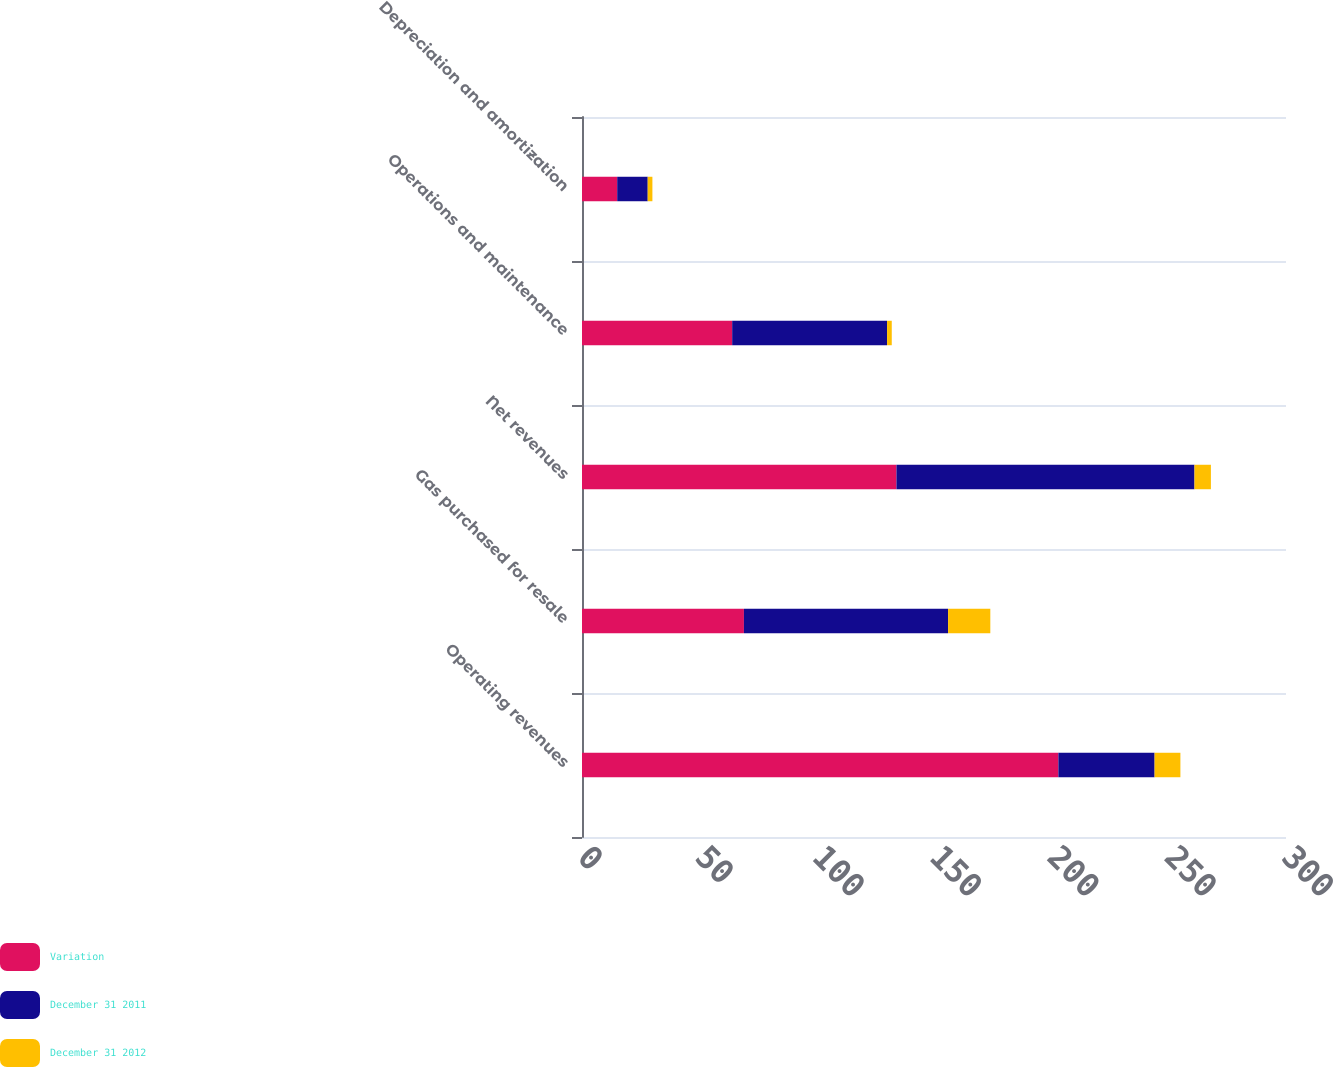<chart> <loc_0><loc_0><loc_500><loc_500><stacked_bar_chart><ecel><fcel>Operating revenues<fcel>Gas purchased for resale<fcel>Net revenues<fcel>Operations and maintenance<fcel>Depreciation and amortization<nl><fcel>Variation<fcel>203<fcel>69<fcel>134<fcel>64<fcel>15<nl><fcel>December 31 2011<fcel>41<fcel>87<fcel>127<fcel>66<fcel>13<nl><fcel>December 31 2012<fcel>11<fcel>18<fcel>7<fcel>2<fcel>2<nl></chart> 